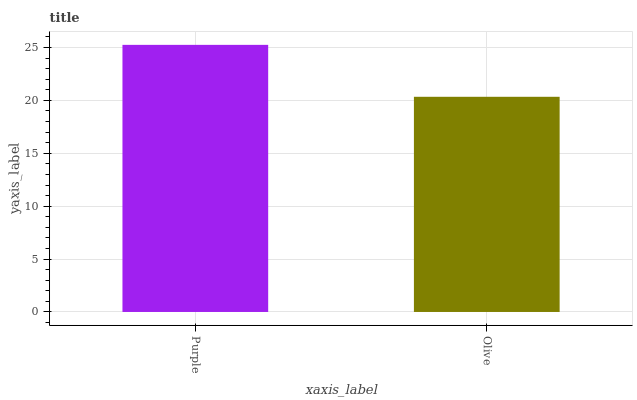Is Olive the minimum?
Answer yes or no. Yes. Is Purple the maximum?
Answer yes or no. Yes. Is Olive the maximum?
Answer yes or no. No. Is Purple greater than Olive?
Answer yes or no. Yes. Is Olive less than Purple?
Answer yes or no. Yes. Is Olive greater than Purple?
Answer yes or no. No. Is Purple less than Olive?
Answer yes or no. No. Is Purple the high median?
Answer yes or no. Yes. Is Olive the low median?
Answer yes or no. Yes. Is Olive the high median?
Answer yes or no. No. Is Purple the low median?
Answer yes or no. No. 